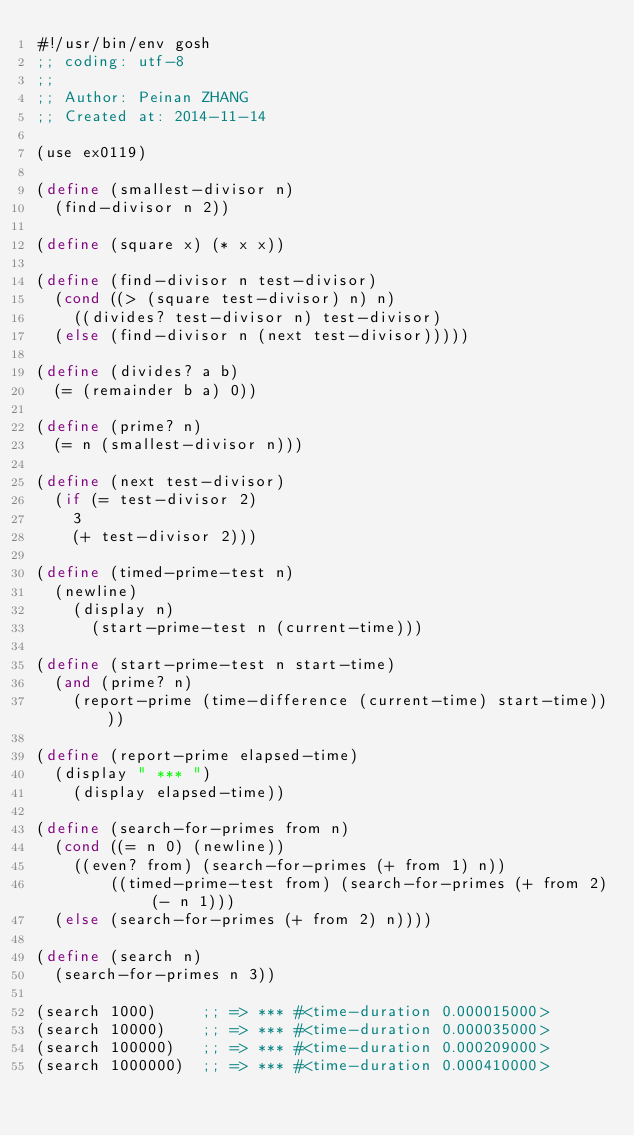Convert code to text. <code><loc_0><loc_0><loc_500><loc_500><_Scheme_>#!/usr/bin/env gosh
;; coding: utf-8
;; 
;; Author: Peinan ZHANG
;; Created at: 2014-11-14

(use ex0119)

(define (smallest-divisor n)
  (find-divisor n 2))

(define (square x) (* x x))

(define (find-divisor n test-divisor)
  (cond ((> (square test-divisor) n) n)
    ((divides? test-divisor n) test-divisor)
  (else (find-divisor n (next test-divisor)))))

(define (divides? a b)
  (= (remainder b a) 0))

(define (prime? n)
  (= n (smallest-divisor n)))

(define (next test-divisor)
  (if (= test-divisor 2)
    3
    (+ test-divisor 2)))

(define (timed-prime-test n)
  (newline)
    (display n)
      (start-prime-test n (current-time)))

(define (start-prime-test n start-time)
  (and (prime? n)
    (report-prime (time-difference (current-time) start-time))))

(define (report-prime elapsed-time)
  (display " *** ")
    (display elapsed-time))

(define (search-for-primes from n)
  (cond ((= n 0) (newline))
    ((even? from) (search-for-primes (+ from 1) n))
        ((timed-prime-test from) (search-for-primes (+ from 2) (- n 1)))
  (else (search-for-primes (+ from 2) n))))

(define (search n)
  (search-for-primes n 3))

(search 1000)     ;; => *** #<time-duration 0.000015000>
(search 10000)    ;; => *** #<time-duration 0.000035000>
(search 100000)   ;; => *** #<time-duration 0.000209000>
(search 1000000)  ;; => *** #<time-duration 0.000410000>
</code> 